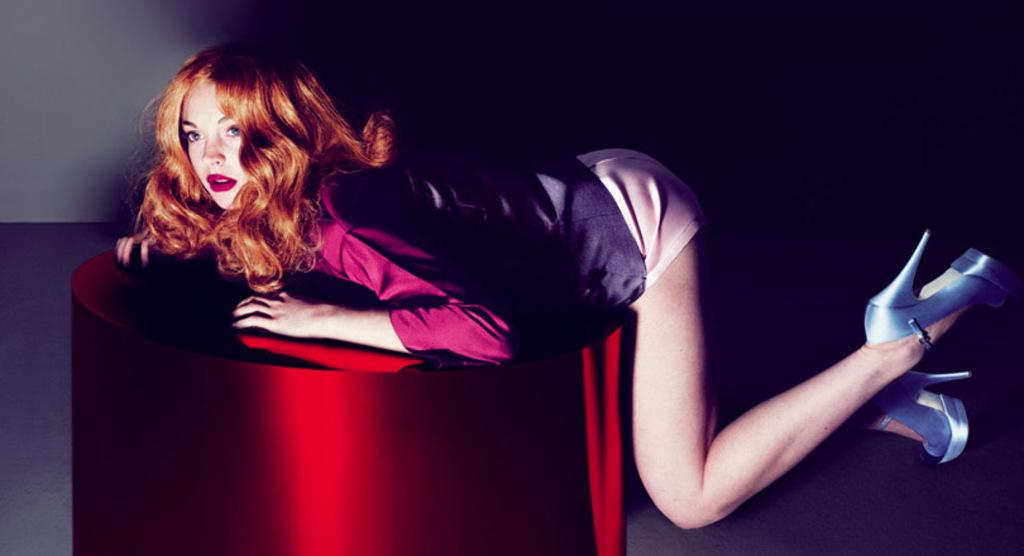Who is the main subject in the image? There is a woman in the image. What is the woman standing on? The woman is standing on a red color block. What can be observed about the background of the image? The background of the image is dark. What type of system is the woman using to communicate with the cattle in the image? There are no cattle present in the image, and the woman is not using any system to communicate with them. 